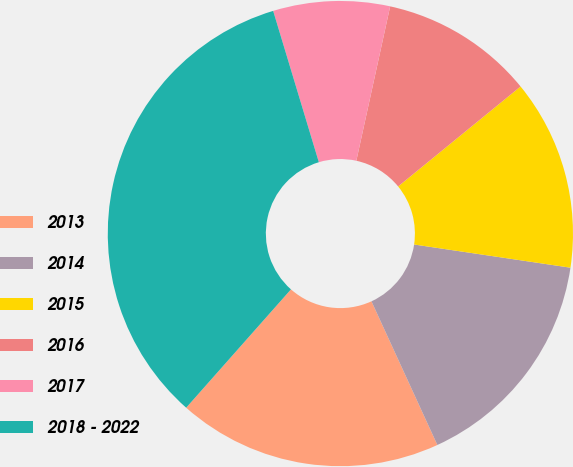Convert chart to OTSL. <chart><loc_0><loc_0><loc_500><loc_500><pie_chart><fcel>2013<fcel>2014<fcel>2015<fcel>2016<fcel>2017<fcel>2018 - 2022<nl><fcel>18.38%<fcel>15.81%<fcel>13.24%<fcel>10.67%<fcel>8.1%<fcel>33.8%<nl></chart> 